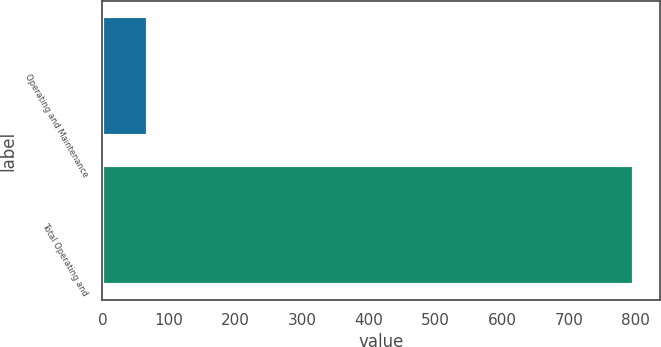Convert chart. <chart><loc_0><loc_0><loc_500><loc_500><bar_chart><fcel>Operating and Maintenance<fcel>Total Operating and<nl><fcel>69<fcel>797.5<nl></chart> 